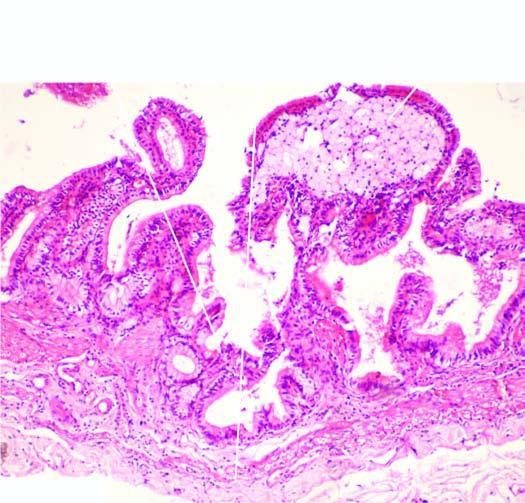does the lamina propria of the mucosa show foamy macrophages?
Answer the question using a single word or phrase. Yes 